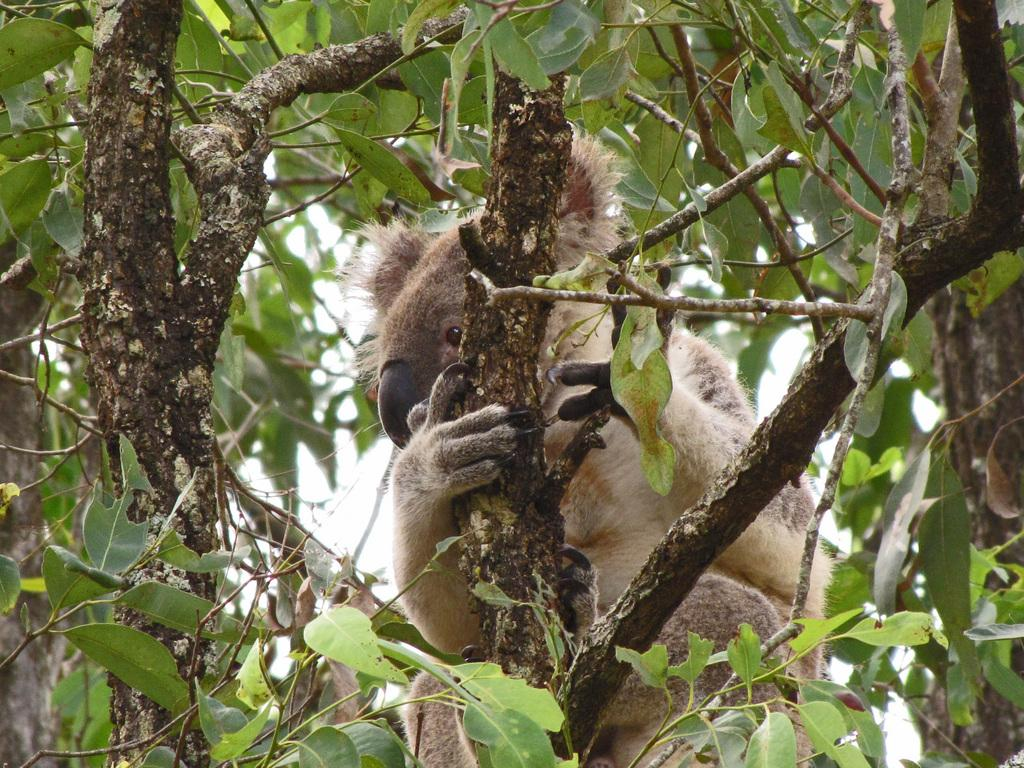What type of animal is in the image? There is an animal in the image, but the specific type cannot be determined from the provided facts. What can be seen in the background of the image? There are trees and the sky visible in the background of the image. What type of brass instrument is being played by the animal in the image? There is no brass instrument or indication of any musical activity in the image. 